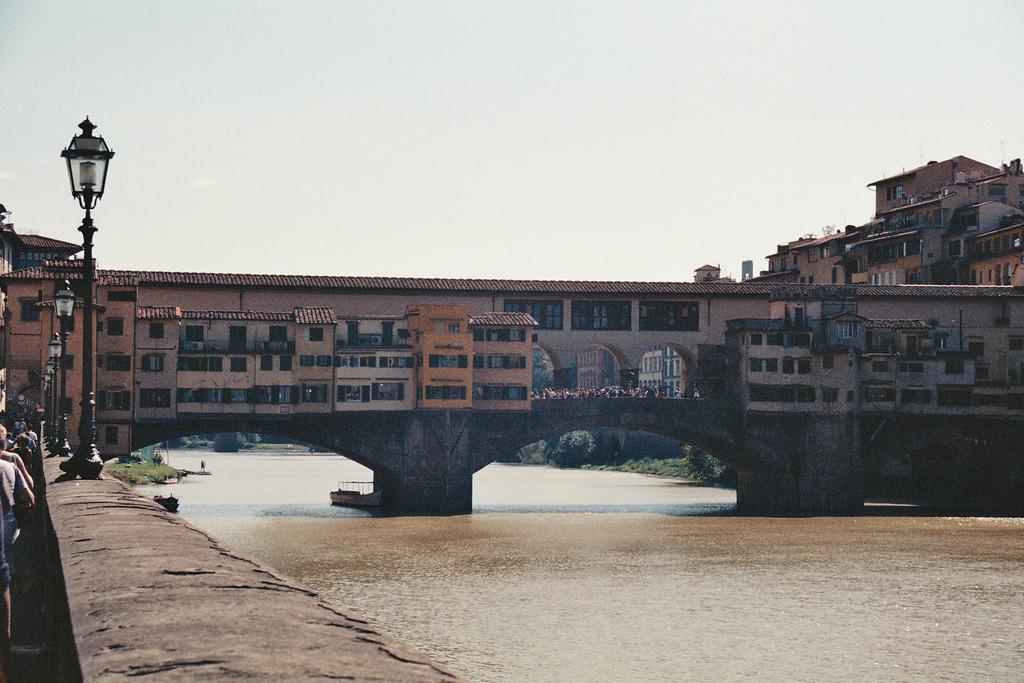Could you give a brief overview of what you see in this image? In this image I can see the water, the wall, few persons standing on the ground, few poles, few buildings and in the background I can see few trees and the sky. 